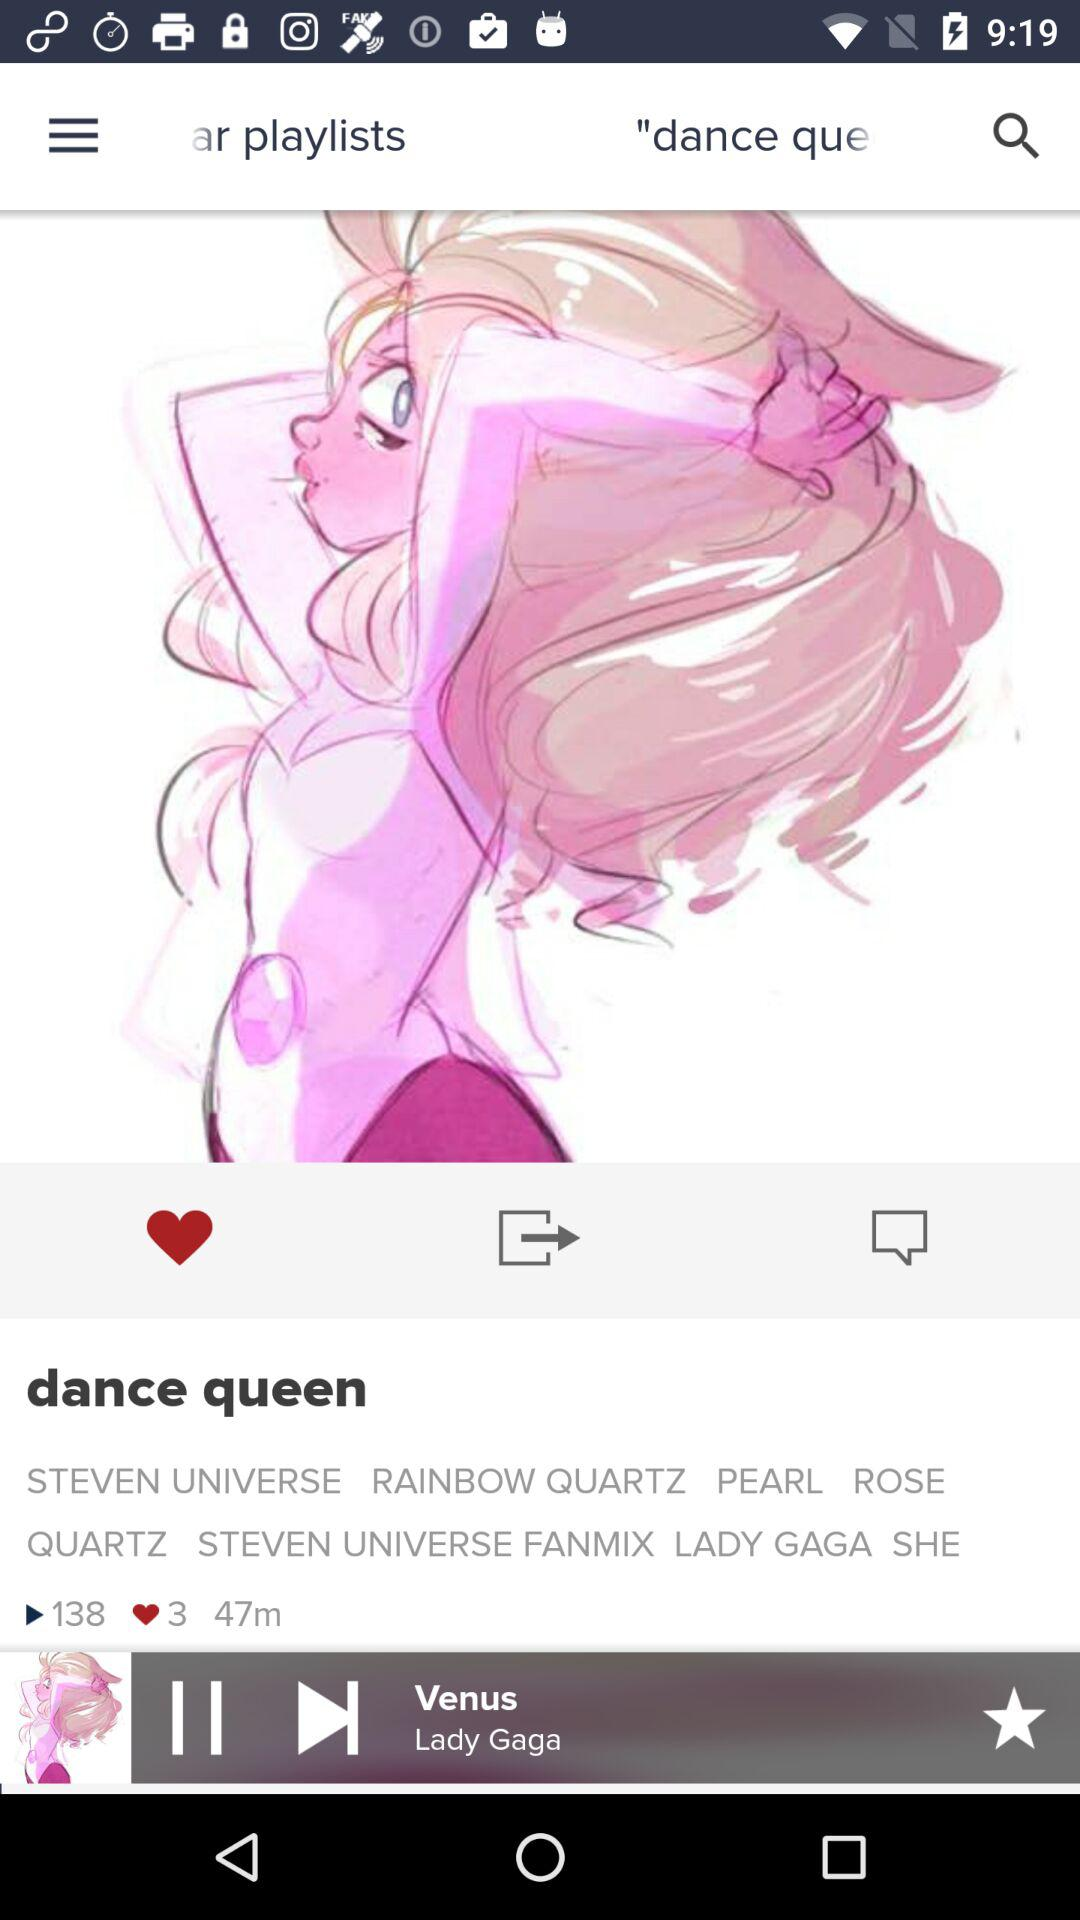Who's the singer of the song "Venus"? The singer of the song is Lady Gaga. 